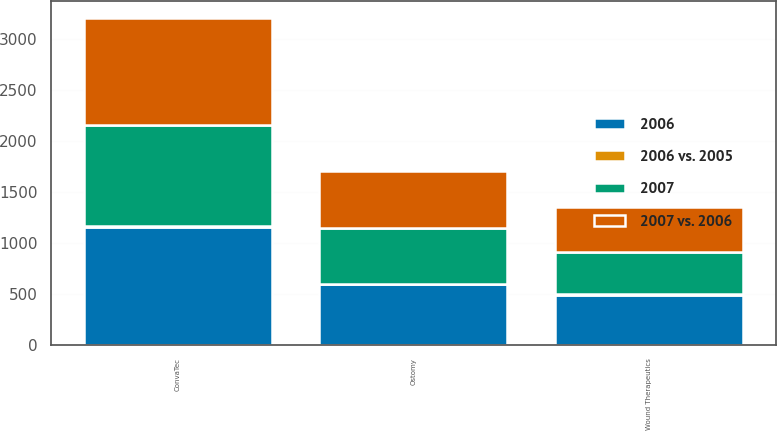Convert chart. <chart><loc_0><loc_0><loc_500><loc_500><stacked_bar_chart><ecel><fcel>ConvaTec<fcel>Ostomy<fcel>Wound Therapeutics<nl><fcel>2006<fcel>1155<fcel>594<fcel>488<nl><fcel>2007 vs. 2006<fcel>1048<fcel>554<fcel>441<nl><fcel>2007<fcel>992<fcel>550<fcel>416<nl><fcel>2006 vs. 2005<fcel>10<fcel>7<fcel>11<nl></chart> 